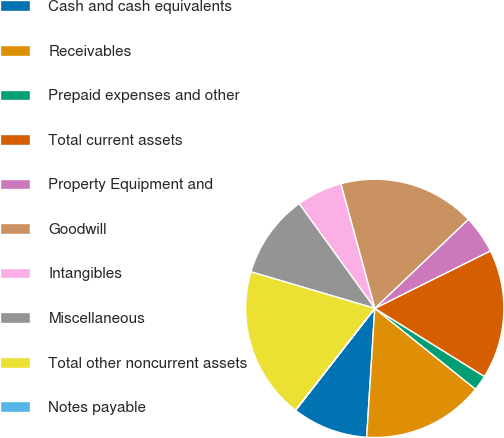Convert chart. <chart><loc_0><loc_0><loc_500><loc_500><pie_chart><fcel>Cash and cash equivalents<fcel>Receivables<fcel>Prepaid expenses and other<fcel>Total current assets<fcel>Property Equipment and<fcel>Goodwill<fcel>Intangibles<fcel>Miscellaneous<fcel>Total other noncurrent assets<fcel>Notes payable<nl><fcel>9.52%<fcel>15.24%<fcel>1.91%<fcel>16.19%<fcel>4.76%<fcel>17.14%<fcel>5.72%<fcel>10.48%<fcel>19.04%<fcel>0.01%<nl></chart> 